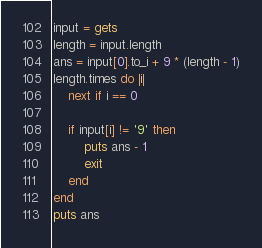Convert code to text. <code><loc_0><loc_0><loc_500><loc_500><_Ruby_>input = gets
length = input.length
ans = input[0].to_i + 9 * (length - 1)
length.times do |i|
    next if i == 0

    if input[i] != '9' then
        puts ans - 1
        exit
    end
end
puts ans
</code> 